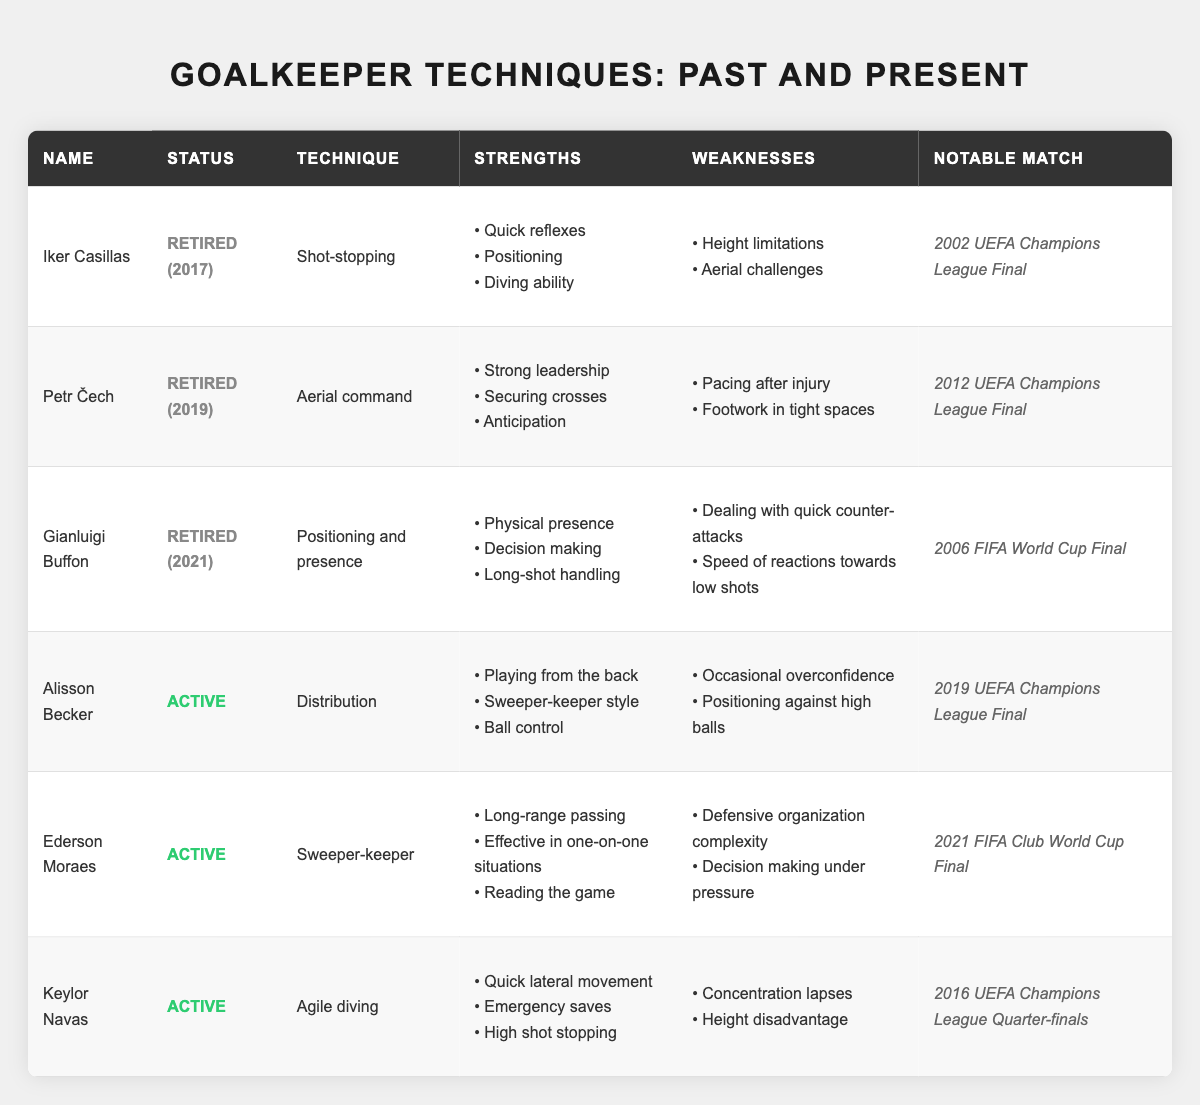What is the notable match for Iker Casillas? The table lists "2002 UEFA Champions League Final" under the notable match for Iker Casillas.
Answer: 2002 UEFA Champions League Final Which goalkeeper uses the technique "Sweeper-keeper"? The table shows that "Ederson Moraes" uses the technique "Sweeper-keeper".
Answer: Ederson Moraes How many strengths does Petr Čech have listed in the table? The table lists three strengths for Petr Čech: "Strong leadership," "Securing crosses," and "Anticipation".
Answer: 3 Is Gianluigi Buffon still an active goalkeeper? The table indicates that Gianluigi Buffon is retired as of 2021, thus he is not active.
Answer: No Which retired goalkeeper has the technique focused on "Aerial command"? The table specifies that Petr Čech has the technique "Aerial command" and is retired.
Answer: Petr Čech What are the weaknesses of Alisson Becker? According to the table, Alisson Becker's weaknesses are "Occasional overconfidence" and "Positioning against high balls".
Answer: Occasional overconfidence and Positioning against high balls Which active goalkeeper has a notable match in the 2019 UEFA Champions League Final? The table states that Alisson Becker had his notable match in the 2019 UEFA Champions League Final.
Answer: Alisson Becker Do both active goalkeepers have strengths related to ball distribution? Ederson Moraes lists "Long-range passing," while Alisson Becker mentions "Playing from the back." Since both have strengths in ball distribution, the answer is yes.
Answer: Yes What is the primary technique of Keylor Navas, and how does it differ from Iker Casillas? Keylor Navas uses "Agile diving" while Iker Casillas focuses on "Shot-stopping." These techniques differ as one emphasizes agility and lateral movement while the other emphasizes reactive saves.
Answer: Agile diving vs. Shot-stopping Name the goalkeeper with a notable match in the 2006 FIFA World Cup Final. The table indicates that Gianluigi Buffon had a notable match in the 2006 FIFA World Cup Final.
Answer: Gianluigi Buffon How many goalkeepers listed have retired post-2017? Three goalkeepers are listed: Iker Casillas (2017), Petr Čech (2019), and Gianluigi Buffon (2021), so only two have retired post-2017 (Čech and Buffon).
Answer: 2 